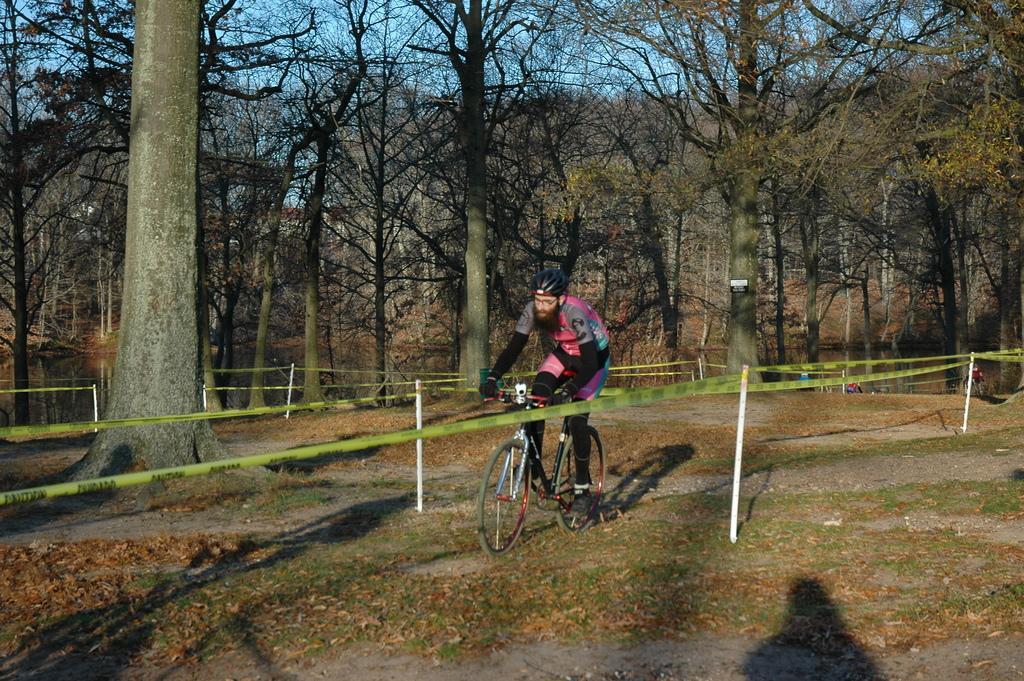How would you summarize this image in a sentence or two? In this image I can see a person riding bicycle. Background I can see few poles in white color, few dried trees and few trees in green color and sky is in blue color. 